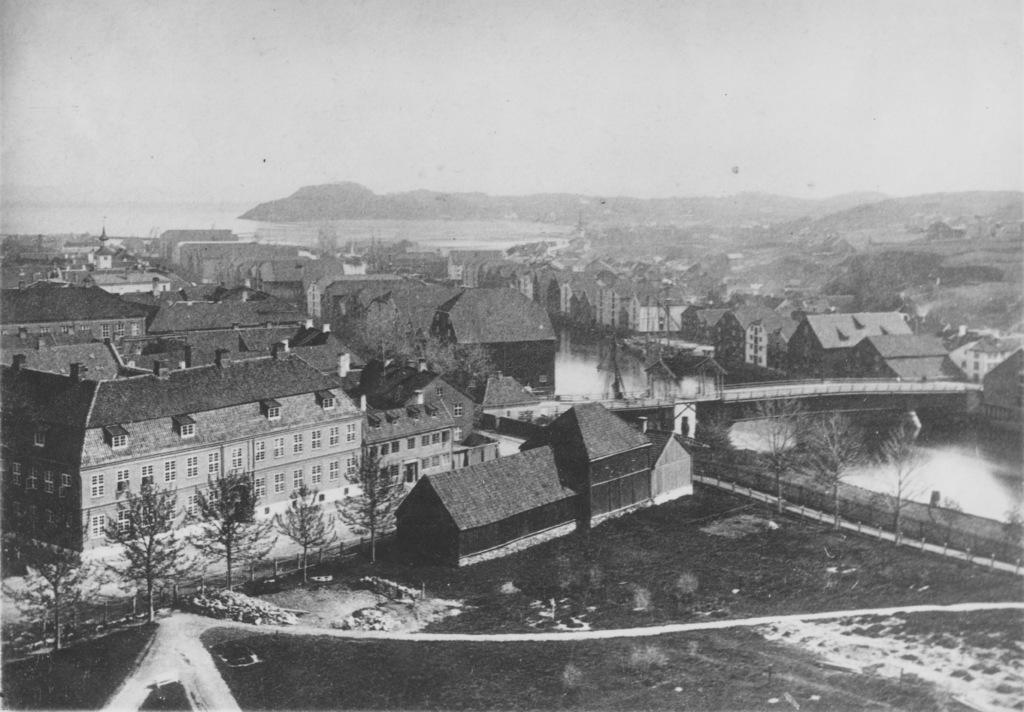What type of structures can be seen in the image? There are houses in the image. What other natural elements are present in the image? There are trees and water visible in the image. What part of the natural environment is visible in the image? The sky is visible in the image. How many potatoes can be seen in the image? There are no potatoes present in the image. What angle is the image taken from? The angle from which the image is taken is not mentioned in the provided facts. 